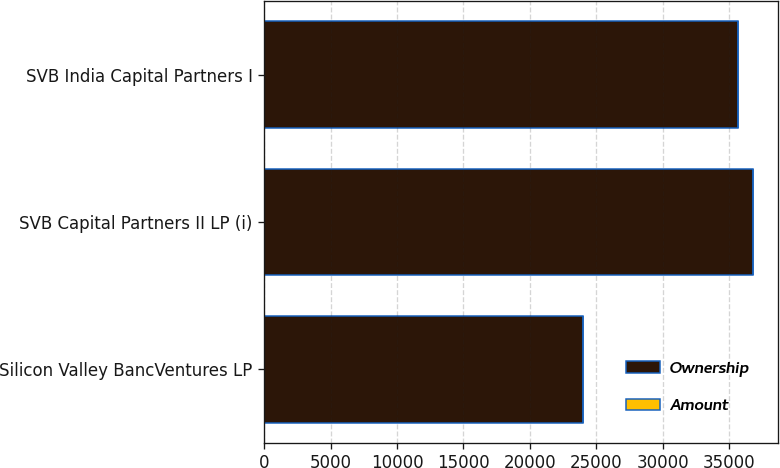Convert chart. <chart><loc_0><loc_0><loc_500><loc_500><stacked_bar_chart><ecel><fcel>Silicon Valley BancVentures LP<fcel>SVB Capital Partners II LP (i)<fcel>SVB India Capital Partners I<nl><fcel>Ownership<fcel>24023<fcel>36847<fcel>35707<nl><fcel>Amount<fcel>10.7<fcel>5.1<fcel>14.4<nl></chart> 